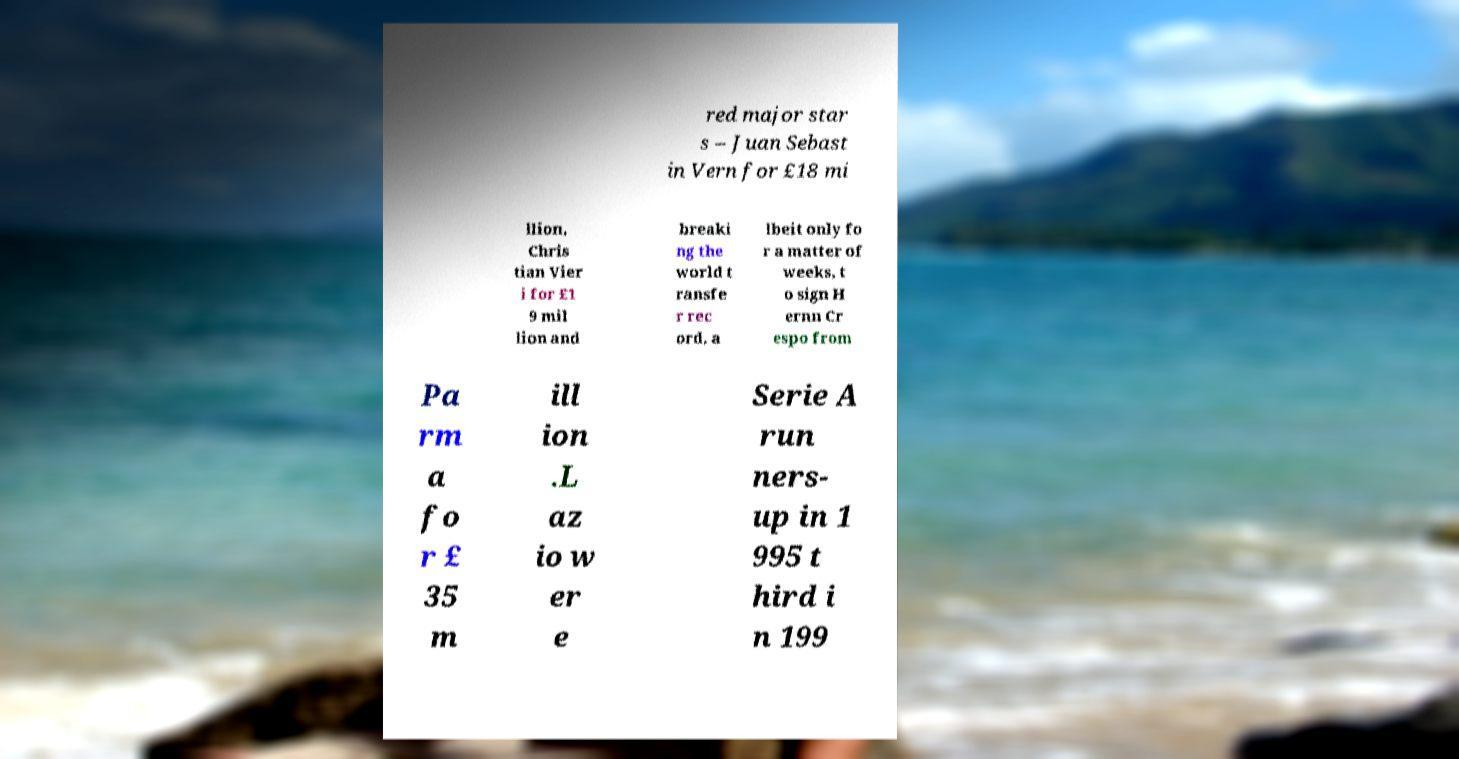Can you read and provide the text displayed in the image?This photo seems to have some interesting text. Can you extract and type it out for me? red major star s – Juan Sebast in Vern for £18 mi llion, Chris tian Vier i for £1 9 mil lion and breaki ng the world t ransfe r rec ord, a lbeit only fo r a matter of weeks, t o sign H ernn Cr espo from Pa rm a fo r £ 35 m ill ion .L az io w er e Serie A run ners- up in 1 995 t hird i n 199 